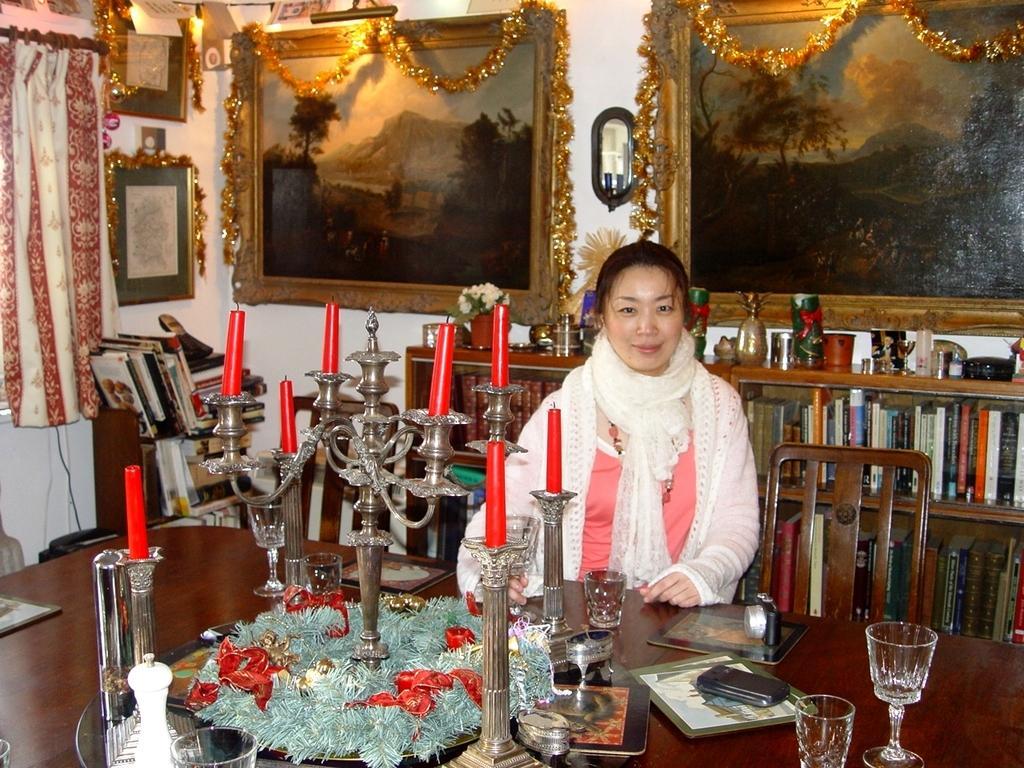Could you give a brief overview of what you see in this image? Here we can see a woman who is sitting on the chair. This is table. On the table there are glasses, mobile, book, and candles. On the background there is a rack and there are some books. There is a wall and these are the frames. Here we can see a curtain. 